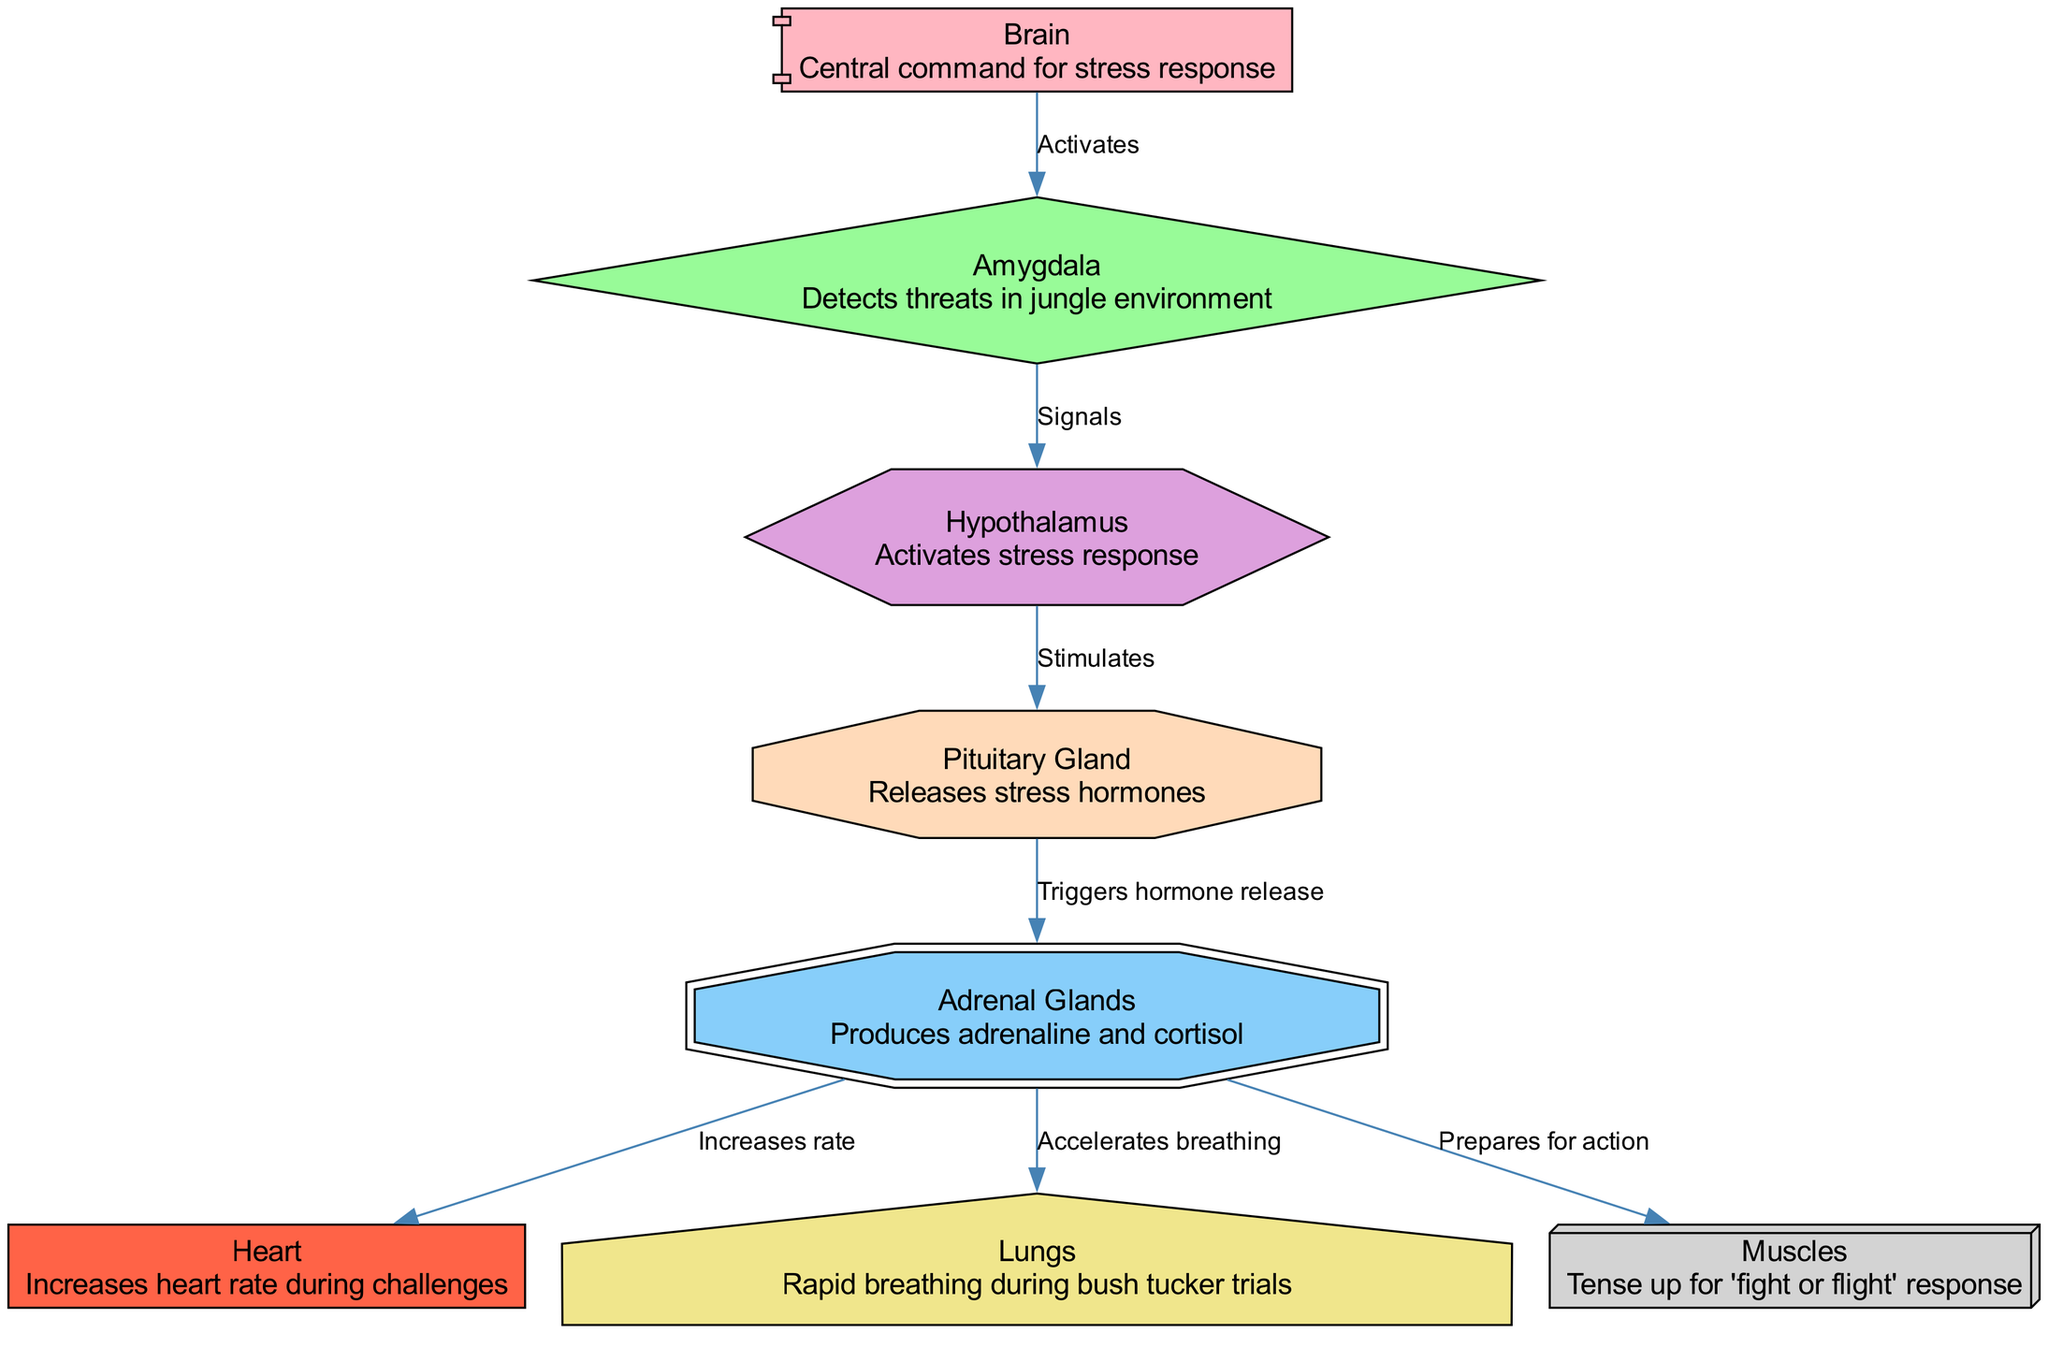What is the central command for stress responses? The diagram identifies the "Brain" as the central command for stress responses, making it the primary node responsible for coordinating the entire response system.
Answer: Brain How many nodes are present in the diagram? By counting the distinct labeled nodes in the diagram, we find there are eight nodes total, each representing a component of the nervous system involved in stress responses.
Answer: 8 What structure detects threats in a jungle environment? The "Amygdala" is labeled in the diagram as responsible for detecting threats, indicating its crucial role in assessing danger during extreme situations like those on 'I'm A Celebrity'.
Answer: Amygdala What does the hypothalamus stimulate? The hypothalamus, indicated in the diagram, plays a vital role by stimulating the "Pituitary Gland" to activate the stress response process upon threat detection.
Answer: Pituitary Which two organs are influenced by the adrenal glands? The diagram shows that the adrenal glands influence the "Heart" and "Lungs," detailing their roles in increasing heart rate and accelerating breathing during stress responses.
Answer: Heart and Lungs What is the effect of the adrenal glands on muscles? The diagram reveals that the adrenal glands prepare the "Muscles" for action as part of the body's 'fight or flight' response during stressful situations.
Answer: Prepares for action How does the amygdala communicate with the hypothalamus? The diagram shows that the amygdala "Signals" the hypothalamus, suggesting a direct communication pathway where the detection of threats triggers subsequent stress response actions.
Answer: Signals What activates the stress response in the body? According to the diagram, the "Hypothalamus" activates the stress response, indicating its critical function in the body's physiological reaction to perceived stress or danger.
Answer: Activates What does the pituitary gland trigger? The "Pituitary Gland" is shown in the diagram to "Trigger hormone release," which is essential for the further activation of stress hormones necessary for the body's response to stress.
Answer: Triggers hormone release 